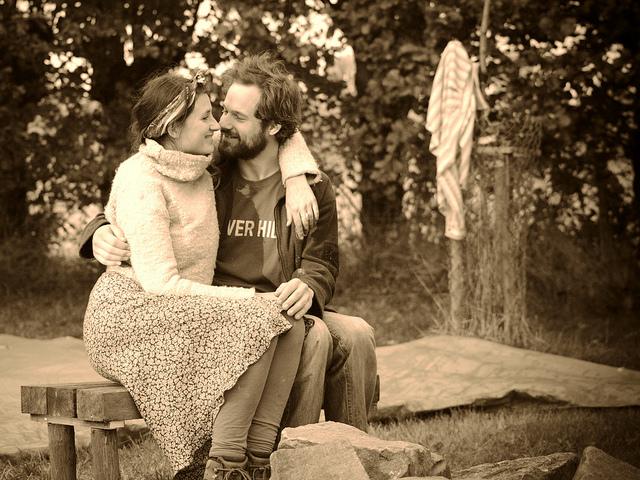What is the couple sitting on?
Concise answer only. Bench. Is this couple cold?
Give a very brief answer. Yes. Is it a hot day?
Be succinct. No. What is the likely relationship of these people?
Concise answer only. Lovers. What is the man giving the woman?
Quick response, please. Kiss. Is this photo more or less than 20 years old?
Write a very short answer. Less. 